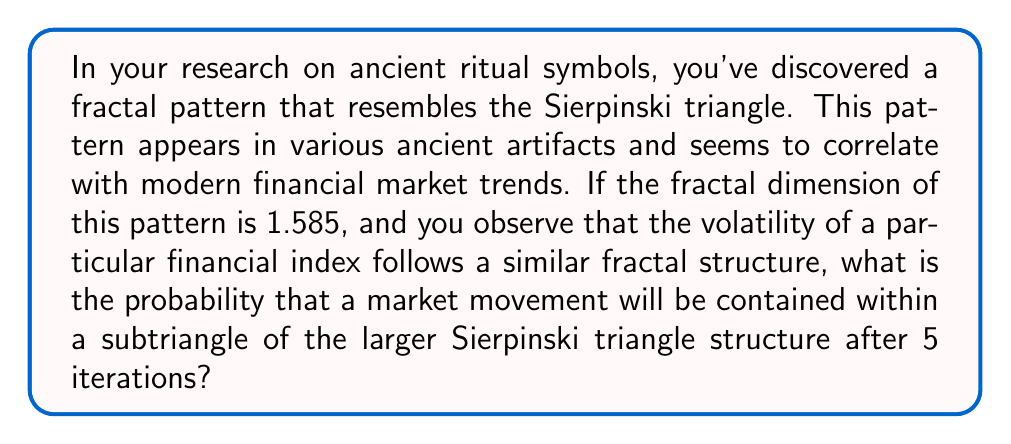Show me your answer to this math problem. To solve this problem, we need to understand the relationship between fractal dimension and the Sierpinski triangle, and how it relates to probability in market movements.

1. The Sierpinski triangle is a self-similar fractal with a fractal dimension of $\log 3 / \log 2 \approx 1.585$.

2. In each iteration of the Sierpinski triangle construction, the number of smaller triangles increases by a factor of 3, while their size decreases by a factor of 2.

3. The probability of a market movement being contained within a subtriangle after n iterations is equal to the ratio of the area of a subtriangle to the total area of the Sierpinski triangle at that iteration.

4. The area of each subtriangle after n iterations is $(1/4)^n$ of the original triangle's area.

5. The number of subtriangles after n iterations is $3^n$.

6. The probability of a market movement being contained within a single subtriangle after n iterations is:

   $$P(n) = \frac{(1/4)^n}{3^n} = (\frac{1}{12})^n$$

7. For 5 iterations:

   $$P(5) = (\frac{1}{12})^5 = \frac{1}{248832}$$

Therefore, the probability of a market movement being contained within a subtriangle of the larger Sierpinski triangle structure after 5 iterations is approximately 0.000004018 or about 0.0004018%.
Answer: $\frac{1}{248832}$ or approximately 0.000004018 (0.0004018%) 